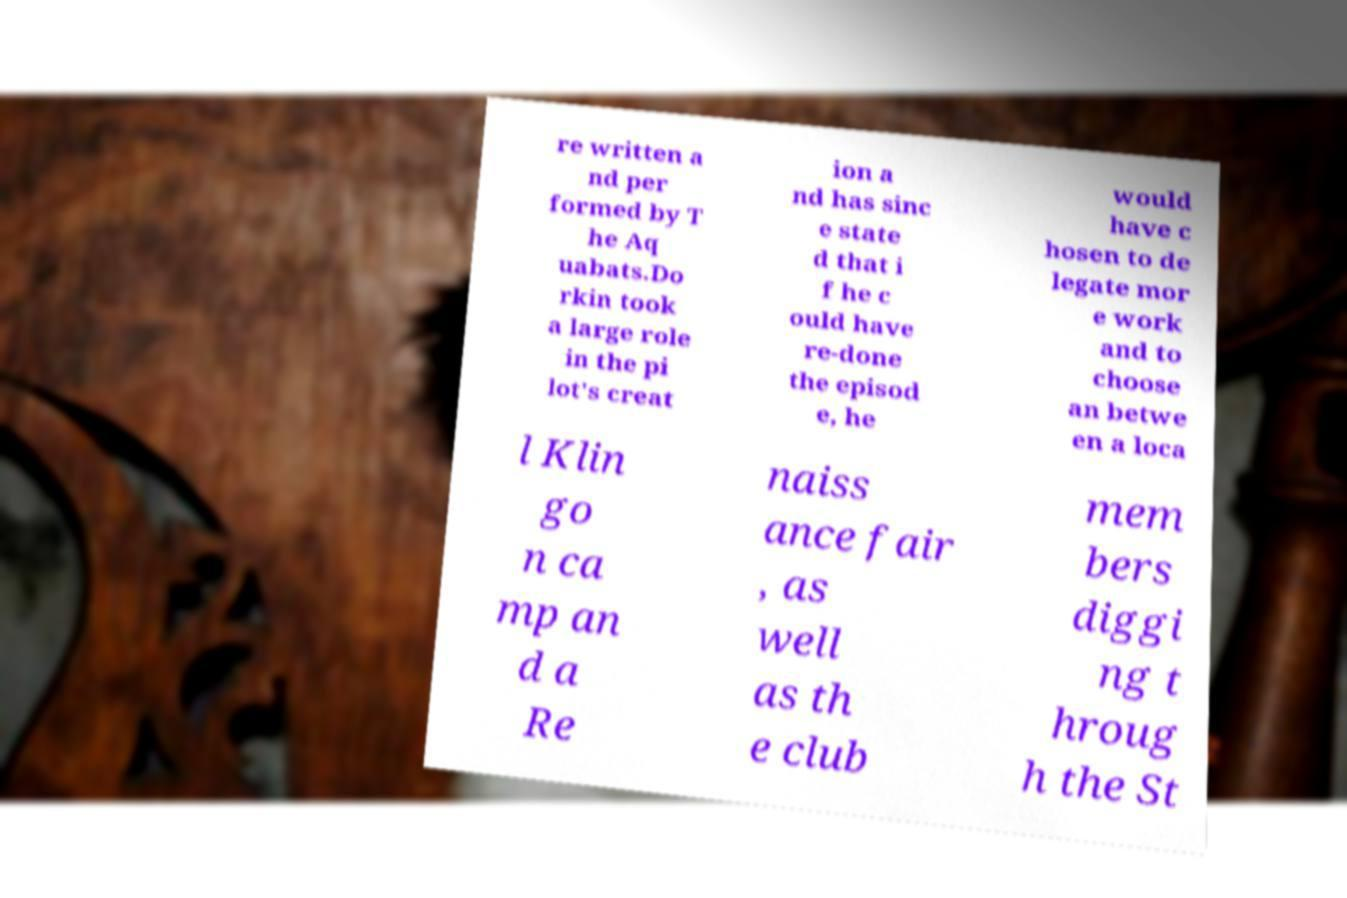There's text embedded in this image that I need extracted. Can you transcribe it verbatim? re written a nd per formed by T he Aq uabats.Do rkin took a large role in the pi lot's creat ion a nd has sinc e state d that i f he c ould have re-done the episod e, he would have c hosen to de legate mor e work and to choose an betwe en a loca l Klin go n ca mp an d a Re naiss ance fair , as well as th e club mem bers diggi ng t hroug h the St 